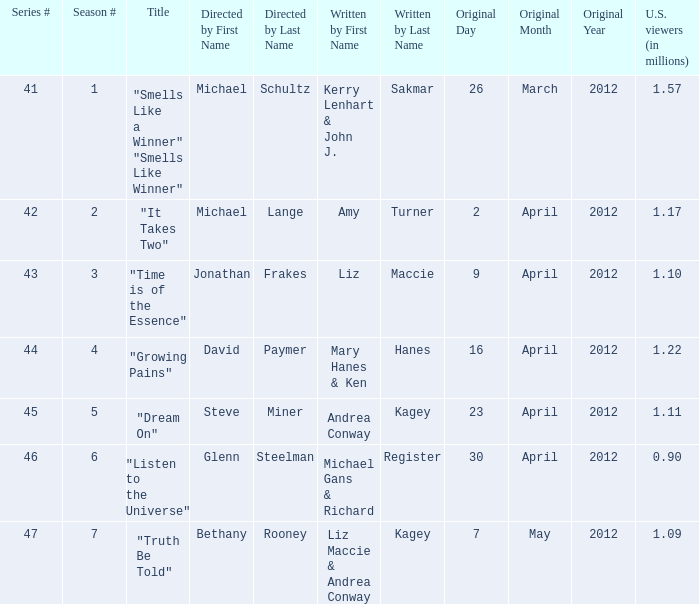How many millions of viewers did the episode written by Andrea Conway Kagey? 1.11. 